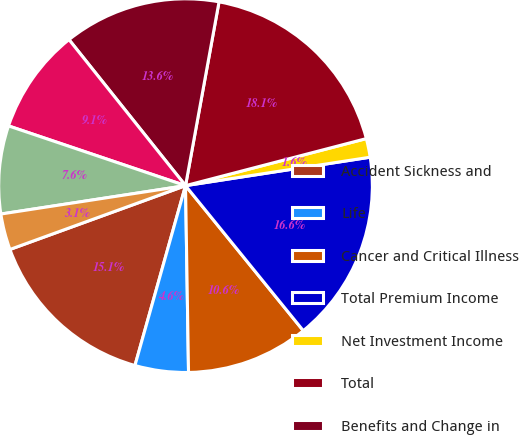Convert chart to OTSL. <chart><loc_0><loc_0><loc_500><loc_500><pie_chart><fcel>Accident Sickness and<fcel>Life<fcel>Cancer and Critical Illness<fcel>Total Premium Income<fcel>Net Investment Income<fcel>Total<fcel>Benefits and Change in<fcel>Commissions<fcel>Deferral of Acquisition Costs<fcel>Amortization of Deferred<nl><fcel>15.09%<fcel>4.62%<fcel>10.6%<fcel>16.58%<fcel>1.62%<fcel>18.08%<fcel>13.59%<fcel>9.1%<fcel>7.61%<fcel>3.12%<nl></chart> 